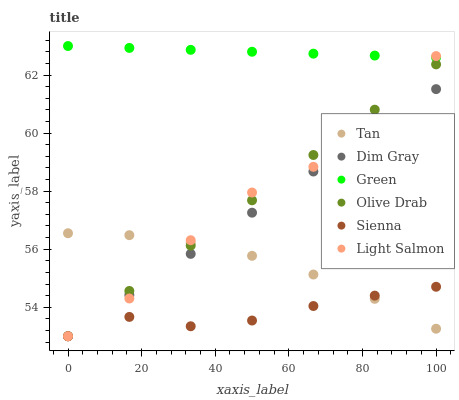Does Sienna have the minimum area under the curve?
Answer yes or no. Yes. Does Green have the maximum area under the curve?
Answer yes or no. Yes. Does Dim Gray have the minimum area under the curve?
Answer yes or no. No. Does Dim Gray have the maximum area under the curve?
Answer yes or no. No. Is Green the smoothest?
Answer yes or no. Yes. Is Light Salmon the roughest?
Answer yes or no. Yes. Is Dim Gray the smoothest?
Answer yes or no. No. Is Dim Gray the roughest?
Answer yes or no. No. Does Light Salmon have the lowest value?
Answer yes or no. Yes. Does Green have the lowest value?
Answer yes or no. No. Does Green have the highest value?
Answer yes or no. Yes. Does Dim Gray have the highest value?
Answer yes or no. No. Is Sienna less than Green?
Answer yes or no. Yes. Is Green greater than Sienna?
Answer yes or no. Yes. Does Green intersect Light Salmon?
Answer yes or no. Yes. Is Green less than Light Salmon?
Answer yes or no. No. Is Green greater than Light Salmon?
Answer yes or no. No. Does Sienna intersect Green?
Answer yes or no. No. 